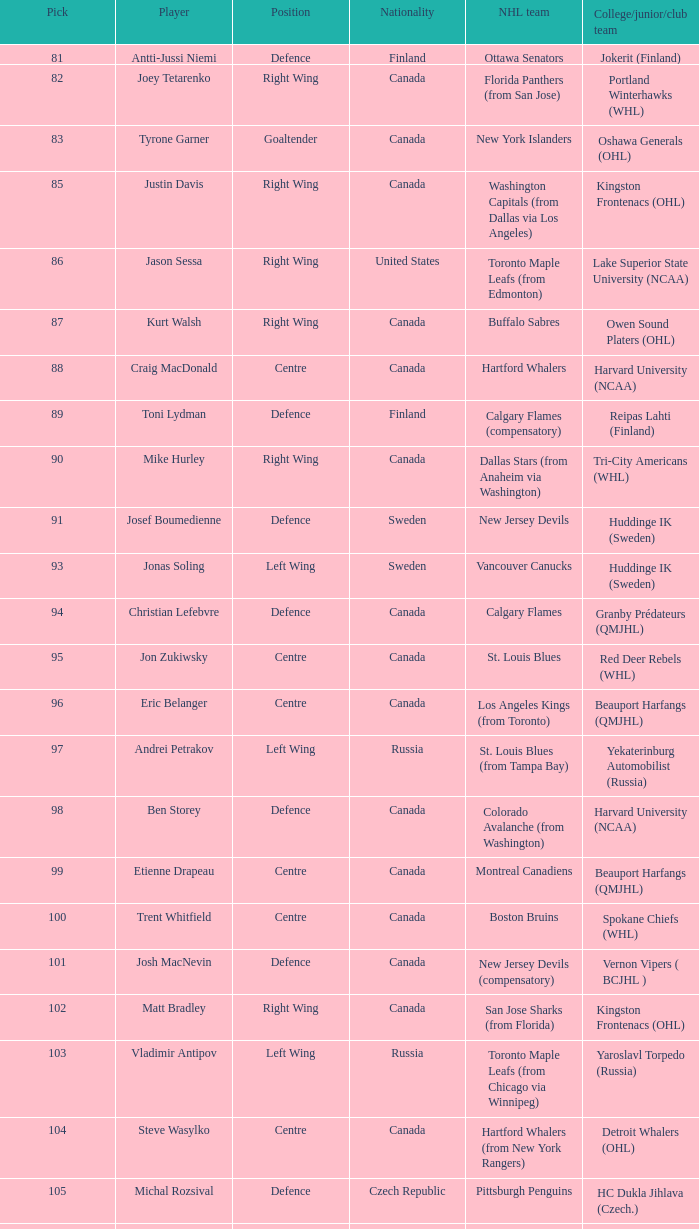What number of draft pick places did matt bradley possess? 1.0. 